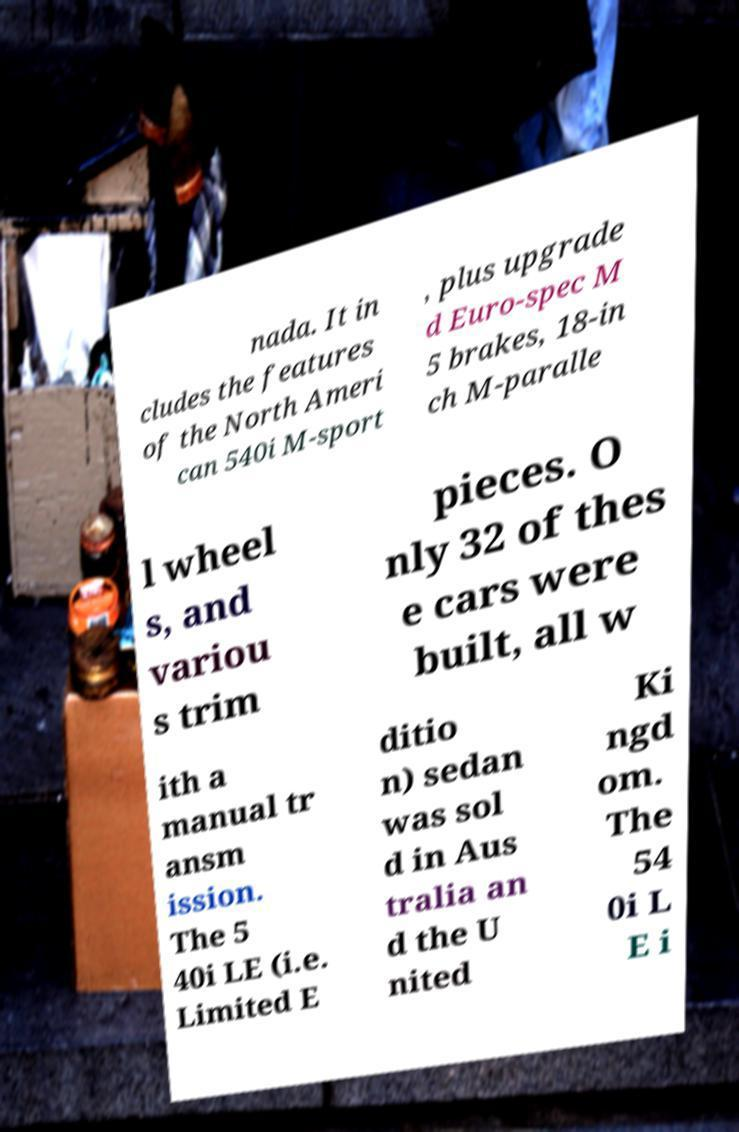Please read and relay the text visible in this image. What does it say? nada. It in cludes the features of the North Ameri can 540i M-sport , plus upgrade d Euro-spec M 5 brakes, 18-in ch M-paralle l wheel s, and variou s trim pieces. O nly 32 of thes e cars were built, all w ith a manual tr ansm ission. The 5 40i LE (i.e. Limited E ditio n) sedan was sol d in Aus tralia an d the U nited Ki ngd om. The 54 0i L E i 